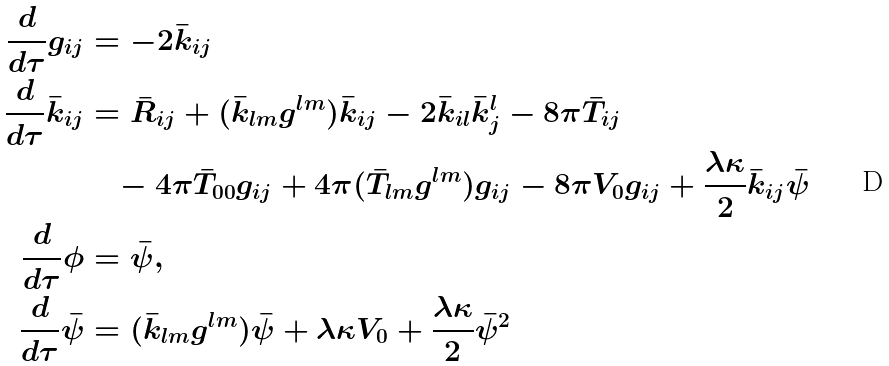<formula> <loc_0><loc_0><loc_500><loc_500>\frac { d } { d \tau } g _ { i j } & = - 2 \bar { k } _ { i j } \\ \frac { d } { d \tau } \bar { k } _ { i j } & = \bar { R } _ { i j } + ( \bar { k } _ { l m } g ^ { l m } ) \bar { k } _ { i j } - 2 \bar { k } _ { i l } \bar { k } ^ { l } _ { j } - 8 \pi \bar { T } _ { i j } \\ & \quad - 4 \pi \bar { T } _ { 0 0 } g _ { i j } + 4 \pi ( \bar { T } _ { l m } g ^ { l m } ) g _ { i j } - 8 \pi V _ { 0 } g _ { i j } + \frac { \lambda \kappa } { 2 } \bar { k } _ { i j } \bar { \psi } \\ \frac { d } { d \tau } \phi & = \bar { \psi } , \\ \frac { d } { d \tau } \bar { \psi } & = ( \bar { k } _ { l m } g ^ { l m } ) \bar { \psi } + \lambda \kappa V _ { 0 } + \frac { \lambda \kappa } { 2 } \bar { \psi } ^ { 2 }</formula> 